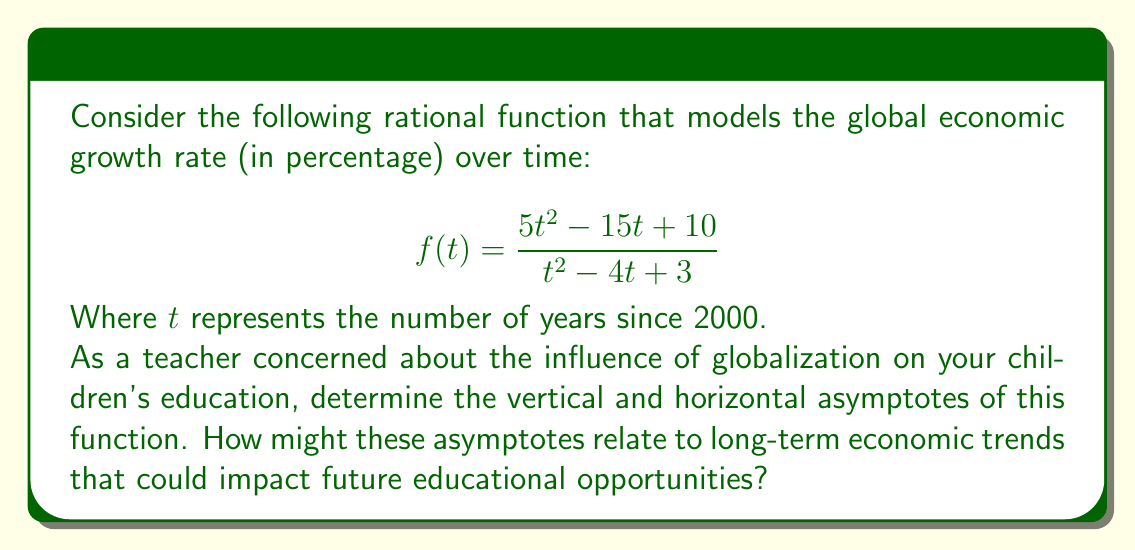Provide a solution to this math problem. Let's find the asymptotes step by step:

1) Vertical Asymptotes:
   Vertical asymptotes occur when the denominator equals zero.
   Solve $t^2 - 4t + 3 = 0$
   $(t - 1)(t - 3) = 0$
   $t = 1$ or $t = 3$

2) Horizontal Asymptote:
   To find the horizontal asymptote, compare the degrees of the numerator and denominator.
   Both have degree 2, so we divide the leading coefficients:
   $\lim_{t \to \infty} \frac{5t^2}{t^2} = 5$

3) Slant Asymptote:
   Since the degree of the numerator equals the degree of the denominator, there is no slant asymptote.

Interpretation:
- Vertical asymptotes at $t = 1$ and $t = 3$ suggest potential economic instabilities in 2001 and 2003.
- The horizontal asymptote of 5 indicates that the long-term global economic growth rate may stabilize around 5%.

These trends could impact future educational opportunities by affecting funding, global job markets, and the skills required for future careers.
Answer: Vertical asymptotes: $t = 1, t = 3$; Horizontal asymptote: $y = 5$ 